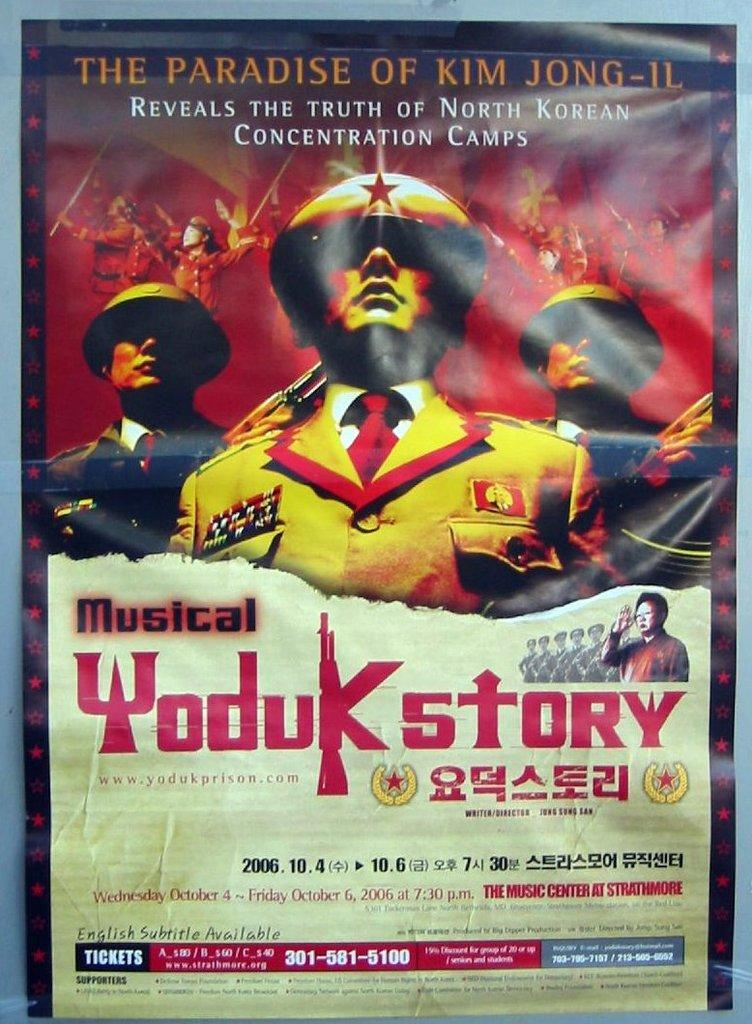Provide a one-sentence caption for the provided image. Poster for a musical titled "Yoduk Story" which takes place on October 4th. 